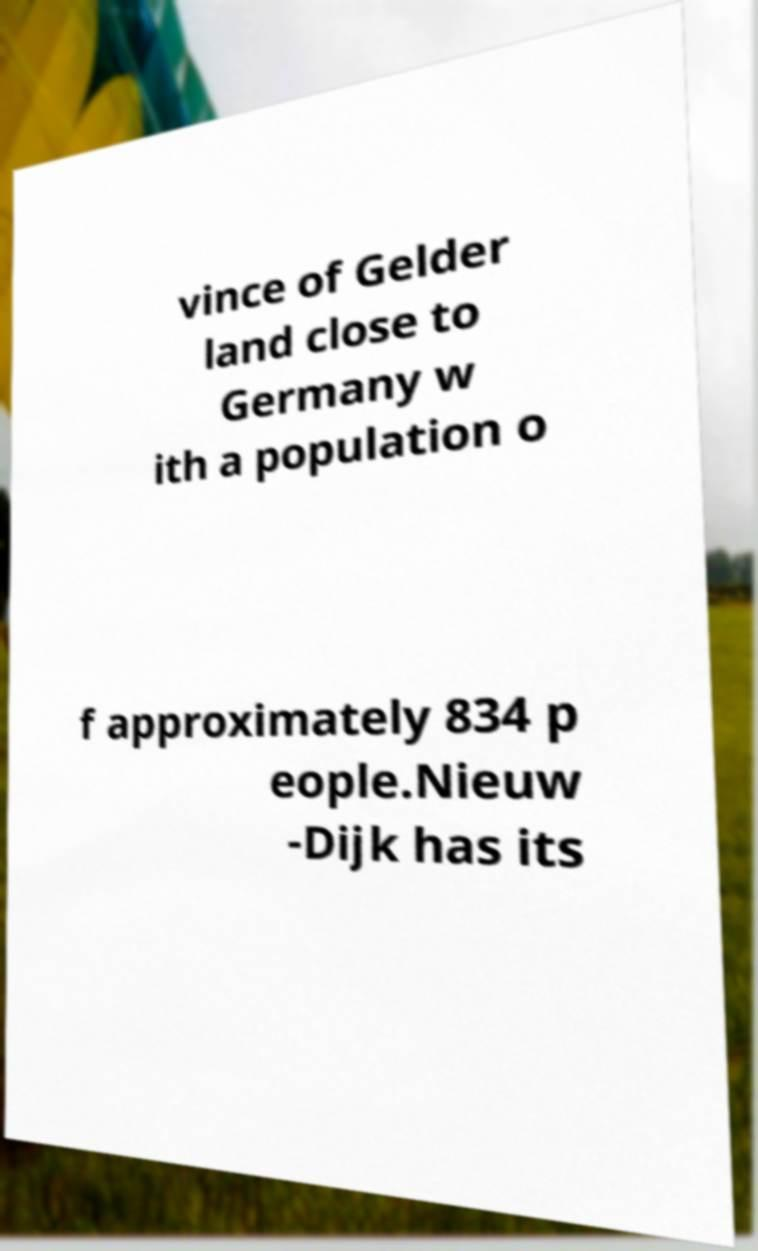Could you extract and type out the text from this image? vince of Gelder land close to Germany w ith a population o f approximately 834 p eople.Nieuw -Dijk has its 